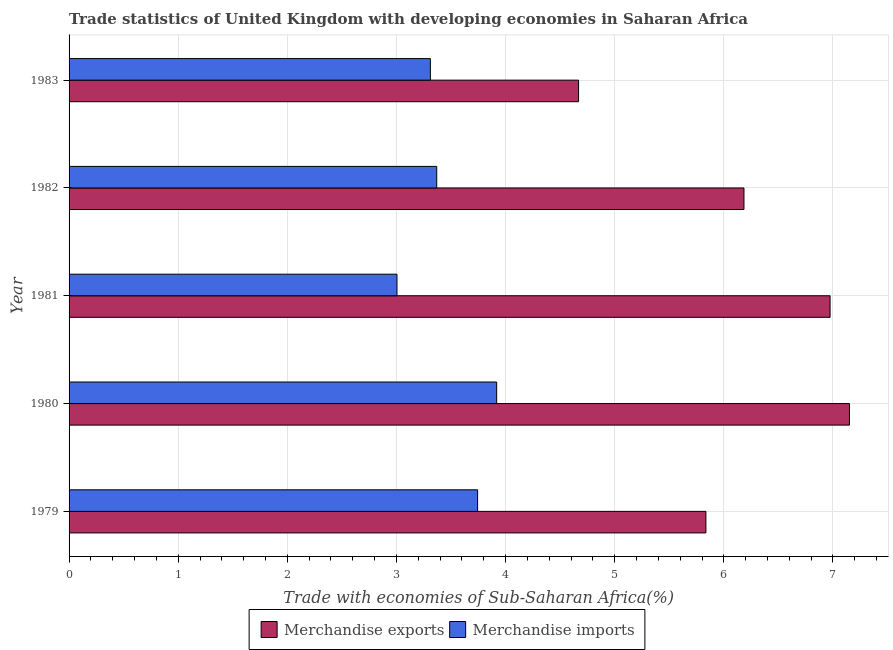How many different coloured bars are there?
Your response must be concise. 2. Are the number of bars on each tick of the Y-axis equal?
Keep it short and to the point. Yes. In how many cases, is the number of bars for a given year not equal to the number of legend labels?
Your answer should be compact. 0. What is the merchandise exports in 1981?
Provide a short and direct response. 6.97. Across all years, what is the maximum merchandise imports?
Ensure brevity in your answer.  3.92. Across all years, what is the minimum merchandise imports?
Your answer should be very brief. 3. What is the total merchandise exports in the graph?
Keep it short and to the point. 30.81. What is the difference between the merchandise exports in 1980 and that in 1983?
Keep it short and to the point. 2.48. What is the difference between the merchandise imports in 1979 and the merchandise exports in 1980?
Ensure brevity in your answer.  -3.41. What is the average merchandise exports per year?
Make the answer very short. 6.16. In the year 1979, what is the difference between the merchandise exports and merchandise imports?
Your response must be concise. 2.09. In how many years, is the merchandise exports greater than 5.8 %?
Your answer should be very brief. 4. What is the ratio of the merchandise imports in 1982 to that in 1983?
Give a very brief answer. 1.02. Is the merchandise exports in 1981 less than that in 1983?
Offer a very short reply. No. Is the difference between the merchandise imports in 1979 and 1981 greater than the difference between the merchandise exports in 1979 and 1981?
Offer a very short reply. Yes. What is the difference between the highest and the second highest merchandise exports?
Provide a succinct answer. 0.18. What is the difference between the highest and the lowest merchandise exports?
Offer a very short reply. 2.48. In how many years, is the merchandise imports greater than the average merchandise imports taken over all years?
Your answer should be compact. 2. Is the sum of the merchandise exports in 1980 and 1982 greater than the maximum merchandise imports across all years?
Your answer should be very brief. Yes. How many bars are there?
Offer a terse response. 10. Are all the bars in the graph horizontal?
Ensure brevity in your answer.  Yes. Does the graph contain grids?
Your answer should be very brief. Yes. How many legend labels are there?
Make the answer very short. 2. What is the title of the graph?
Give a very brief answer. Trade statistics of United Kingdom with developing economies in Saharan Africa. Does "Resident" appear as one of the legend labels in the graph?
Your response must be concise. No. What is the label or title of the X-axis?
Provide a succinct answer. Trade with economies of Sub-Saharan Africa(%). What is the Trade with economies of Sub-Saharan Africa(%) in Merchandise exports in 1979?
Your response must be concise. 5.84. What is the Trade with economies of Sub-Saharan Africa(%) in Merchandise imports in 1979?
Offer a terse response. 3.74. What is the Trade with economies of Sub-Saharan Africa(%) in Merchandise exports in 1980?
Keep it short and to the point. 7.15. What is the Trade with economies of Sub-Saharan Africa(%) in Merchandise imports in 1980?
Offer a very short reply. 3.92. What is the Trade with economies of Sub-Saharan Africa(%) in Merchandise exports in 1981?
Your answer should be compact. 6.97. What is the Trade with economies of Sub-Saharan Africa(%) in Merchandise imports in 1981?
Make the answer very short. 3. What is the Trade with economies of Sub-Saharan Africa(%) in Merchandise exports in 1982?
Your response must be concise. 6.18. What is the Trade with economies of Sub-Saharan Africa(%) of Merchandise imports in 1982?
Your response must be concise. 3.37. What is the Trade with economies of Sub-Saharan Africa(%) in Merchandise exports in 1983?
Provide a short and direct response. 4.67. What is the Trade with economies of Sub-Saharan Africa(%) in Merchandise imports in 1983?
Give a very brief answer. 3.31. Across all years, what is the maximum Trade with economies of Sub-Saharan Africa(%) in Merchandise exports?
Offer a very short reply. 7.15. Across all years, what is the maximum Trade with economies of Sub-Saharan Africa(%) of Merchandise imports?
Provide a succinct answer. 3.92. Across all years, what is the minimum Trade with economies of Sub-Saharan Africa(%) in Merchandise exports?
Keep it short and to the point. 4.67. Across all years, what is the minimum Trade with economies of Sub-Saharan Africa(%) of Merchandise imports?
Make the answer very short. 3. What is the total Trade with economies of Sub-Saharan Africa(%) in Merchandise exports in the graph?
Offer a terse response. 30.81. What is the total Trade with economies of Sub-Saharan Africa(%) of Merchandise imports in the graph?
Your answer should be compact. 17.35. What is the difference between the Trade with economies of Sub-Saharan Africa(%) of Merchandise exports in 1979 and that in 1980?
Your response must be concise. -1.32. What is the difference between the Trade with economies of Sub-Saharan Africa(%) in Merchandise imports in 1979 and that in 1980?
Your response must be concise. -0.17. What is the difference between the Trade with economies of Sub-Saharan Africa(%) in Merchandise exports in 1979 and that in 1981?
Your answer should be compact. -1.14. What is the difference between the Trade with economies of Sub-Saharan Africa(%) in Merchandise imports in 1979 and that in 1981?
Your answer should be compact. 0.74. What is the difference between the Trade with economies of Sub-Saharan Africa(%) in Merchandise exports in 1979 and that in 1982?
Give a very brief answer. -0.35. What is the difference between the Trade with economies of Sub-Saharan Africa(%) in Merchandise imports in 1979 and that in 1982?
Offer a terse response. 0.37. What is the difference between the Trade with economies of Sub-Saharan Africa(%) of Merchandise imports in 1979 and that in 1983?
Offer a very short reply. 0.43. What is the difference between the Trade with economies of Sub-Saharan Africa(%) of Merchandise exports in 1980 and that in 1981?
Your answer should be compact. 0.18. What is the difference between the Trade with economies of Sub-Saharan Africa(%) of Merchandise imports in 1980 and that in 1981?
Give a very brief answer. 0.91. What is the difference between the Trade with economies of Sub-Saharan Africa(%) of Merchandise exports in 1980 and that in 1982?
Keep it short and to the point. 0.97. What is the difference between the Trade with economies of Sub-Saharan Africa(%) in Merchandise imports in 1980 and that in 1982?
Offer a very short reply. 0.55. What is the difference between the Trade with economies of Sub-Saharan Africa(%) of Merchandise exports in 1980 and that in 1983?
Keep it short and to the point. 2.48. What is the difference between the Trade with economies of Sub-Saharan Africa(%) of Merchandise imports in 1980 and that in 1983?
Make the answer very short. 0.61. What is the difference between the Trade with economies of Sub-Saharan Africa(%) in Merchandise exports in 1981 and that in 1982?
Offer a terse response. 0.79. What is the difference between the Trade with economies of Sub-Saharan Africa(%) of Merchandise imports in 1981 and that in 1982?
Provide a succinct answer. -0.36. What is the difference between the Trade with economies of Sub-Saharan Africa(%) in Merchandise exports in 1981 and that in 1983?
Offer a very short reply. 2.3. What is the difference between the Trade with economies of Sub-Saharan Africa(%) in Merchandise imports in 1981 and that in 1983?
Your answer should be very brief. -0.31. What is the difference between the Trade with economies of Sub-Saharan Africa(%) in Merchandise exports in 1982 and that in 1983?
Your answer should be very brief. 1.52. What is the difference between the Trade with economies of Sub-Saharan Africa(%) in Merchandise imports in 1982 and that in 1983?
Offer a very short reply. 0.06. What is the difference between the Trade with economies of Sub-Saharan Africa(%) of Merchandise exports in 1979 and the Trade with economies of Sub-Saharan Africa(%) of Merchandise imports in 1980?
Keep it short and to the point. 1.92. What is the difference between the Trade with economies of Sub-Saharan Africa(%) in Merchandise exports in 1979 and the Trade with economies of Sub-Saharan Africa(%) in Merchandise imports in 1981?
Provide a short and direct response. 2.83. What is the difference between the Trade with economies of Sub-Saharan Africa(%) of Merchandise exports in 1979 and the Trade with economies of Sub-Saharan Africa(%) of Merchandise imports in 1982?
Make the answer very short. 2.47. What is the difference between the Trade with economies of Sub-Saharan Africa(%) of Merchandise exports in 1979 and the Trade with economies of Sub-Saharan Africa(%) of Merchandise imports in 1983?
Your response must be concise. 2.52. What is the difference between the Trade with economies of Sub-Saharan Africa(%) of Merchandise exports in 1980 and the Trade with economies of Sub-Saharan Africa(%) of Merchandise imports in 1981?
Ensure brevity in your answer.  4.15. What is the difference between the Trade with economies of Sub-Saharan Africa(%) of Merchandise exports in 1980 and the Trade with economies of Sub-Saharan Africa(%) of Merchandise imports in 1982?
Provide a succinct answer. 3.78. What is the difference between the Trade with economies of Sub-Saharan Africa(%) in Merchandise exports in 1980 and the Trade with economies of Sub-Saharan Africa(%) in Merchandise imports in 1983?
Offer a very short reply. 3.84. What is the difference between the Trade with economies of Sub-Saharan Africa(%) of Merchandise exports in 1981 and the Trade with economies of Sub-Saharan Africa(%) of Merchandise imports in 1982?
Offer a terse response. 3.6. What is the difference between the Trade with economies of Sub-Saharan Africa(%) of Merchandise exports in 1981 and the Trade with economies of Sub-Saharan Africa(%) of Merchandise imports in 1983?
Offer a very short reply. 3.66. What is the difference between the Trade with economies of Sub-Saharan Africa(%) in Merchandise exports in 1982 and the Trade with economies of Sub-Saharan Africa(%) in Merchandise imports in 1983?
Make the answer very short. 2.87. What is the average Trade with economies of Sub-Saharan Africa(%) in Merchandise exports per year?
Keep it short and to the point. 6.16. What is the average Trade with economies of Sub-Saharan Africa(%) of Merchandise imports per year?
Keep it short and to the point. 3.47. In the year 1979, what is the difference between the Trade with economies of Sub-Saharan Africa(%) in Merchandise exports and Trade with economies of Sub-Saharan Africa(%) in Merchandise imports?
Provide a short and direct response. 2.09. In the year 1980, what is the difference between the Trade with economies of Sub-Saharan Africa(%) in Merchandise exports and Trade with economies of Sub-Saharan Africa(%) in Merchandise imports?
Your answer should be compact. 3.23. In the year 1981, what is the difference between the Trade with economies of Sub-Saharan Africa(%) of Merchandise exports and Trade with economies of Sub-Saharan Africa(%) of Merchandise imports?
Ensure brevity in your answer.  3.97. In the year 1982, what is the difference between the Trade with economies of Sub-Saharan Africa(%) of Merchandise exports and Trade with economies of Sub-Saharan Africa(%) of Merchandise imports?
Provide a succinct answer. 2.82. In the year 1983, what is the difference between the Trade with economies of Sub-Saharan Africa(%) of Merchandise exports and Trade with economies of Sub-Saharan Africa(%) of Merchandise imports?
Keep it short and to the point. 1.36. What is the ratio of the Trade with economies of Sub-Saharan Africa(%) in Merchandise exports in 1979 to that in 1980?
Make the answer very short. 0.82. What is the ratio of the Trade with economies of Sub-Saharan Africa(%) in Merchandise imports in 1979 to that in 1980?
Your answer should be very brief. 0.96. What is the ratio of the Trade with economies of Sub-Saharan Africa(%) of Merchandise exports in 1979 to that in 1981?
Give a very brief answer. 0.84. What is the ratio of the Trade with economies of Sub-Saharan Africa(%) in Merchandise imports in 1979 to that in 1981?
Your response must be concise. 1.25. What is the ratio of the Trade with economies of Sub-Saharan Africa(%) in Merchandise exports in 1979 to that in 1982?
Keep it short and to the point. 0.94. What is the ratio of the Trade with economies of Sub-Saharan Africa(%) of Merchandise imports in 1979 to that in 1982?
Offer a terse response. 1.11. What is the ratio of the Trade with economies of Sub-Saharan Africa(%) in Merchandise exports in 1979 to that in 1983?
Make the answer very short. 1.25. What is the ratio of the Trade with economies of Sub-Saharan Africa(%) of Merchandise imports in 1979 to that in 1983?
Ensure brevity in your answer.  1.13. What is the ratio of the Trade with economies of Sub-Saharan Africa(%) of Merchandise exports in 1980 to that in 1981?
Make the answer very short. 1.03. What is the ratio of the Trade with economies of Sub-Saharan Africa(%) in Merchandise imports in 1980 to that in 1981?
Your response must be concise. 1.3. What is the ratio of the Trade with economies of Sub-Saharan Africa(%) of Merchandise exports in 1980 to that in 1982?
Offer a very short reply. 1.16. What is the ratio of the Trade with economies of Sub-Saharan Africa(%) of Merchandise imports in 1980 to that in 1982?
Your response must be concise. 1.16. What is the ratio of the Trade with economies of Sub-Saharan Africa(%) of Merchandise exports in 1980 to that in 1983?
Keep it short and to the point. 1.53. What is the ratio of the Trade with economies of Sub-Saharan Africa(%) in Merchandise imports in 1980 to that in 1983?
Provide a succinct answer. 1.18. What is the ratio of the Trade with economies of Sub-Saharan Africa(%) in Merchandise exports in 1981 to that in 1982?
Your answer should be compact. 1.13. What is the ratio of the Trade with economies of Sub-Saharan Africa(%) of Merchandise imports in 1981 to that in 1982?
Your response must be concise. 0.89. What is the ratio of the Trade with economies of Sub-Saharan Africa(%) in Merchandise exports in 1981 to that in 1983?
Provide a short and direct response. 1.49. What is the ratio of the Trade with economies of Sub-Saharan Africa(%) in Merchandise imports in 1981 to that in 1983?
Keep it short and to the point. 0.91. What is the ratio of the Trade with economies of Sub-Saharan Africa(%) of Merchandise exports in 1982 to that in 1983?
Offer a very short reply. 1.32. What is the ratio of the Trade with economies of Sub-Saharan Africa(%) of Merchandise imports in 1982 to that in 1983?
Give a very brief answer. 1.02. What is the difference between the highest and the second highest Trade with economies of Sub-Saharan Africa(%) in Merchandise exports?
Offer a terse response. 0.18. What is the difference between the highest and the second highest Trade with economies of Sub-Saharan Africa(%) in Merchandise imports?
Your response must be concise. 0.17. What is the difference between the highest and the lowest Trade with economies of Sub-Saharan Africa(%) of Merchandise exports?
Keep it short and to the point. 2.48. What is the difference between the highest and the lowest Trade with economies of Sub-Saharan Africa(%) in Merchandise imports?
Ensure brevity in your answer.  0.91. 